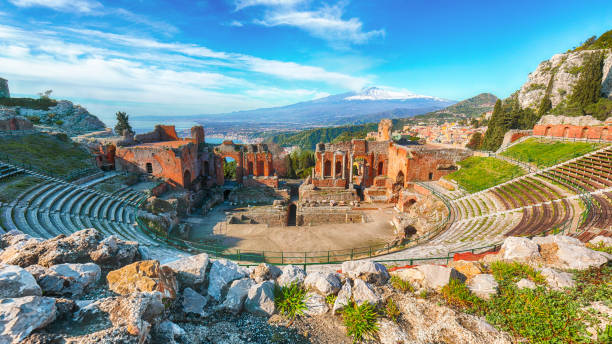If the theater could talk, what stories might it tell? If the ancient theater in Taormina could speak, it would narrate a tapestry of tales spanning centuries. It would recount the grandeur of opening nights filled with the powerful orations of Aeschylus's tragedies and the uproarious laughter from the comedies of Aristophanes. The theater would speak of the sacred festivals dedicated to Dionysus, where the community gathered to celebrate through song, dance, and drama. It would share whispers of political debates once held within its confines, where civic leaders addressed the masses. The stones would echo the tumultuous periods of history, including the Roman adaptations of Greek plays and the shifts in cultural practices over time. It would also remember quieter moments; the gentle breeze sweeping across empty seats, the setting sun casting long shadows, and the stars emerging as silent witnesses to the legacy of human expression. Each story, etched in the ancient stone, would reveal a sliver of the vibrant life that once pulsated in its embrace. Describe a mythical event in this theater involving the gods and heroes of Greek mythology. Imagine a grand festival held in honor of Dionysus, the god of wine and theater, drawing mortals and deities alike. The theater is buzzing with excitement; golden sunlight bathes the arena as spectators fill the seats, anticipating a divine spectacle. Suddenly, the figure of Zeus appears on stage, his presence commanding silence. He is followed by Hera, Athena, and Apollo, each god bringing their intricate stories to life. The arena transforms with each tale – thunder crashes and lightning splits the sky as Zeus recounts his victory over the Titans. Apollo’s melodic lyre fills the air as he narrates his adventures, and Athena demonstrates strategic warfare, her golden armor shimmering. Heroes from myth – Hercules, Perseus, and Odysseus – make their appearances, reenacting their legendary quests with vigor and valor. The climax of the event is a vivid reenactment of Dionysus's birth and his journey from childhood to his ascension as a god. The brilliant storytelling, combined with the backdrop of the Mediterranean and the looming presence of Mount Etna, makes the event otherworldly. It's a night where the boundary between mortal and divine blurs, leaving the audience with a sense of awe and reverence for the mythic tales interwoven with their heritage. If the theater were to host a futuristic event, what would it look like? Picture a futuristic event in the storied theater of Taormina, blending ancient heritage with cutting-edge technology. Holographic projections emerge, recounting the myths of old with vivid realism, as drones soar above, capturing the spectacle from every angle for a global audience viewing in augmented reality. The seating, equipped with AI-guided translation headsets, allows visitors from around the world to appreciate the event in their own languages simultaneously. Bioluminescent flora adorn the ancient stone structures, providing a surreal, ethereal glow as night falls. A symphony of sounds from advanced audio systems creates an immersive experience, surrounding the audience with a 360-degree soundscape. Performers in smart fabrics with LED enhancements bring new colors to traditional costumes, narrating futuristic interpretations of Greek myths. Robotic assistants move gracefully, ensuring the comfort and safety of the guests. As the event unfolds, a mesmerizing laser display plays against the backdrop of Mount Etna, marrying the ancient natural splendor with the marvels of future possibilities. The futuristic event not only honors the rich history of the theater but also propels it into an exciting realm where the legacy of human creativity continues to thrive. 